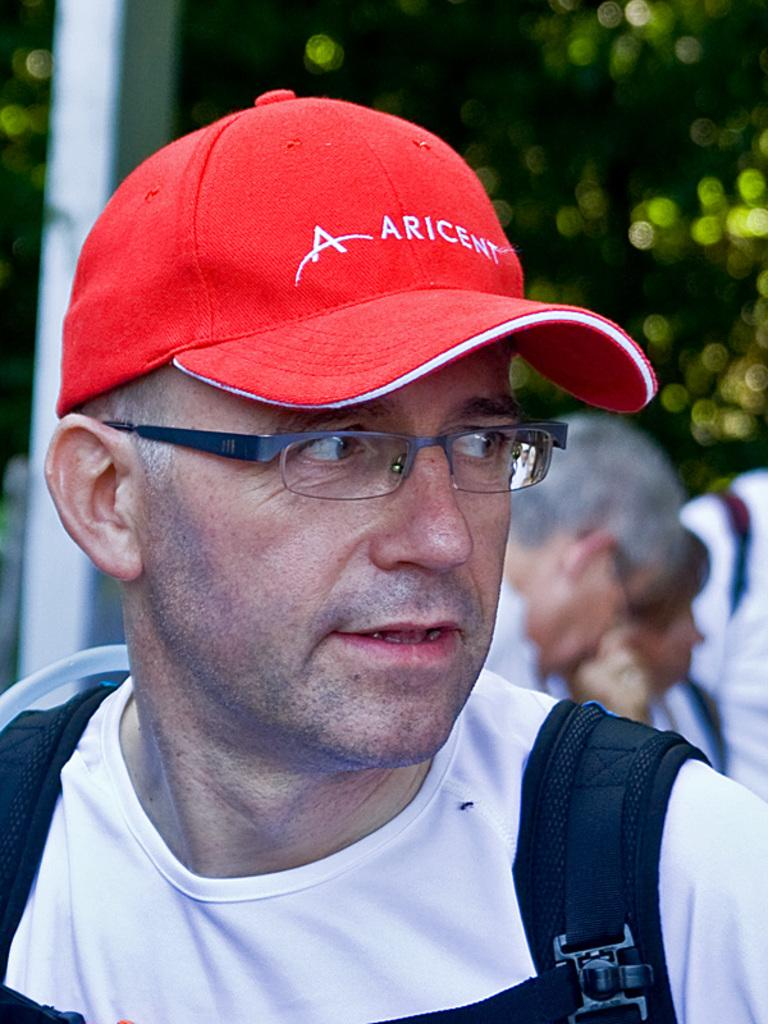What is the person in the image wearing on their upper body? The person is wearing a white T-shirt. What type of headwear is the person wearing? The person is wearing an orange cap. Can you describe the people in the background of the image? The background of the image is blurred, so it is difficult to make out the details of the other persons. What is the overall appearance of the background in the image? The background of the image is blurred. Is there a mailbox visible in the image? There is no mention of a mailbox or mail in the provided facts, so it cannot be determined if one is present in the image. 